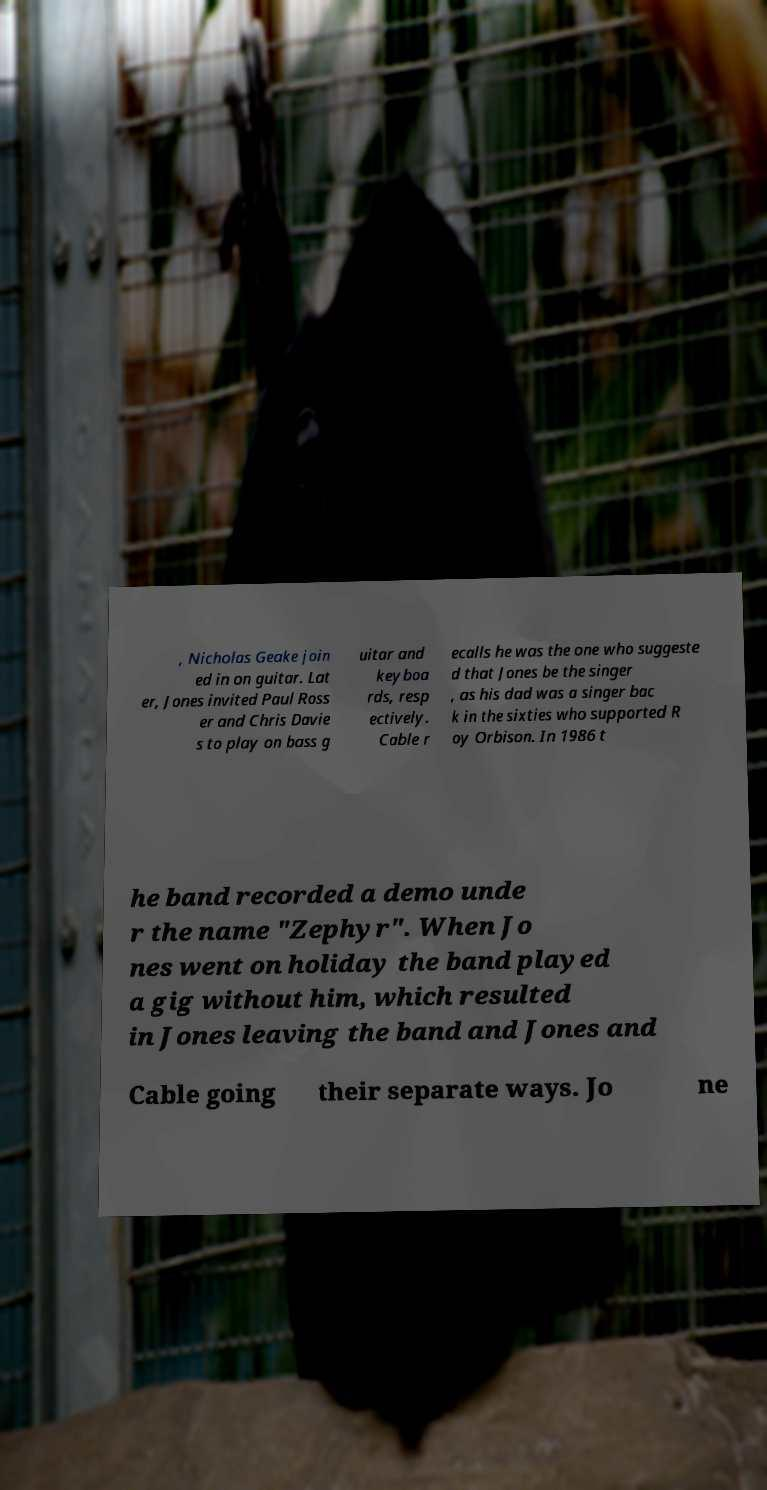Can you accurately transcribe the text from the provided image for me? , Nicholas Geake join ed in on guitar. Lat er, Jones invited Paul Ross er and Chris Davie s to play on bass g uitar and keyboa rds, resp ectively. Cable r ecalls he was the one who suggeste d that Jones be the singer , as his dad was a singer bac k in the sixties who supported R oy Orbison. In 1986 t he band recorded a demo unde r the name "Zephyr". When Jo nes went on holiday the band played a gig without him, which resulted in Jones leaving the band and Jones and Cable going their separate ways. Jo ne 